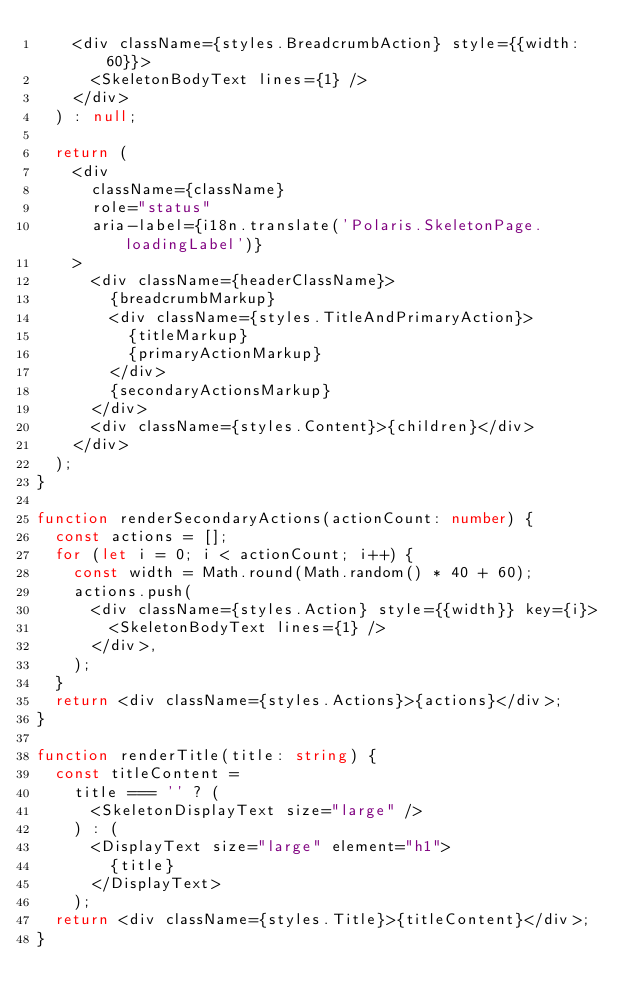<code> <loc_0><loc_0><loc_500><loc_500><_TypeScript_>    <div className={styles.BreadcrumbAction} style={{width: 60}}>
      <SkeletonBodyText lines={1} />
    </div>
  ) : null;

  return (
    <div
      className={className}
      role="status"
      aria-label={i18n.translate('Polaris.SkeletonPage.loadingLabel')}
    >
      <div className={headerClassName}>
        {breadcrumbMarkup}
        <div className={styles.TitleAndPrimaryAction}>
          {titleMarkup}
          {primaryActionMarkup}
        </div>
        {secondaryActionsMarkup}
      </div>
      <div className={styles.Content}>{children}</div>
    </div>
  );
}

function renderSecondaryActions(actionCount: number) {
  const actions = [];
  for (let i = 0; i < actionCount; i++) {
    const width = Math.round(Math.random() * 40 + 60);
    actions.push(
      <div className={styles.Action} style={{width}} key={i}>
        <SkeletonBodyText lines={1} />
      </div>,
    );
  }
  return <div className={styles.Actions}>{actions}</div>;
}

function renderTitle(title: string) {
  const titleContent =
    title === '' ? (
      <SkeletonDisplayText size="large" />
    ) : (
      <DisplayText size="large" element="h1">
        {title}
      </DisplayText>
    );
  return <div className={styles.Title}>{titleContent}</div>;
}
</code> 